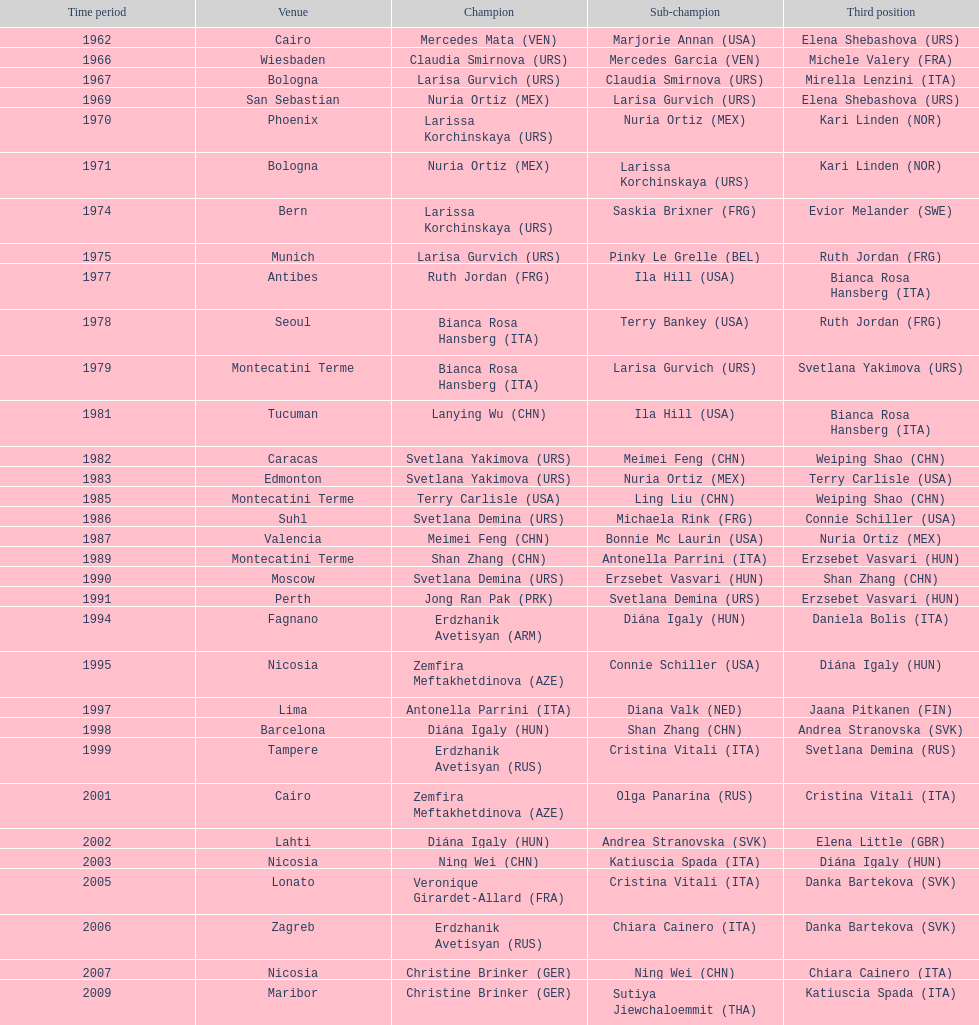How many gold did u.s.a win 1. Can you parse all the data within this table? {'header': ['Time period', 'Venue', 'Champion', 'Sub-champion', 'Third position'], 'rows': [['1962', 'Cairo', 'Mercedes Mata\xa0(VEN)', 'Marjorie Annan\xa0(USA)', 'Elena Shebashova\xa0(URS)'], ['1966', 'Wiesbaden', 'Claudia Smirnova\xa0(URS)', 'Mercedes Garcia\xa0(VEN)', 'Michele Valery\xa0(FRA)'], ['1967', 'Bologna', 'Larisa Gurvich\xa0(URS)', 'Claudia Smirnova\xa0(URS)', 'Mirella Lenzini\xa0(ITA)'], ['1969', 'San Sebastian', 'Nuria Ortiz\xa0(MEX)', 'Larisa Gurvich\xa0(URS)', 'Elena Shebashova\xa0(URS)'], ['1970', 'Phoenix', 'Larissa Korchinskaya\xa0(URS)', 'Nuria Ortiz\xa0(MEX)', 'Kari Linden\xa0(NOR)'], ['1971', 'Bologna', 'Nuria Ortiz\xa0(MEX)', 'Larissa Korchinskaya\xa0(URS)', 'Kari Linden\xa0(NOR)'], ['1974', 'Bern', 'Larissa Korchinskaya\xa0(URS)', 'Saskia Brixner\xa0(FRG)', 'Evior Melander\xa0(SWE)'], ['1975', 'Munich', 'Larisa Gurvich\xa0(URS)', 'Pinky Le Grelle\xa0(BEL)', 'Ruth Jordan\xa0(FRG)'], ['1977', 'Antibes', 'Ruth Jordan\xa0(FRG)', 'Ila Hill\xa0(USA)', 'Bianca Rosa Hansberg\xa0(ITA)'], ['1978', 'Seoul', 'Bianca Rosa Hansberg\xa0(ITA)', 'Terry Bankey\xa0(USA)', 'Ruth Jordan\xa0(FRG)'], ['1979', 'Montecatini Terme', 'Bianca Rosa Hansberg\xa0(ITA)', 'Larisa Gurvich\xa0(URS)', 'Svetlana Yakimova\xa0(URS)'], ['1981', 'Tucuman', 'Lanying Wu\xa0(CHN)', 'Ila Hill\xa0(USA)', 'Bianca Rosa Hansberg\xa0(ITA)'], ['1982', 'Caracas', 'Svetlana Yakimova\xa0(URS)', 'Meimei Feng\xa0(CHN)', 'Weiping Shao\xa0(CHN)'], ['1983', 'Edmonton', 'Svetlana Yakimova\xa0(URS)', 'Nuria Ortiz\xa0(MEX)', 'Terry Carlisle\xa0(USA)'], ['1985', 'Montecatini Terme', 'Terry Carlisle\xa0(USA)', 'Ling Liu\xa0(CHN)', 'Weiping Shao\xa0(CHN)'], ['1986', 'Suhl', 'Svetlana Demina\xa0(URS)', 'Michaela Rink\xa0(FRG)', 'Connie Schiller\xa0(USA)'], ['1987', 'Valencia', 'Meimei Feng\xa0(CHN)', 'Bonnie Mc Laurin\xa0(USA)', 'Nuria Ortiz\xa0(MEX)'], ['1989', 'Montecatini Terme', 'Shan Zhang\xa0(CHN)', 'Antonella Parrini\xa0(ITA)', 'Erzsebet Vasvari\xa0(HUN)'], ['1990', 'Moscow', 'Svetlana Demina\xa0(URS)', 'Erzsebet Vasvari\xa0(HUN)', 'Shan Zhang\xa0(CHN)'], ['1991', 'Perth', 'Jong Ran Pak\xa0(PRK)', 'Svetlana Demina\xa0(URS)', 'Erzsebet Vasvari\xa0(HUN)'], ['1994', 'Fagnano', 'Erdzhanik Avetisyan\xa0(ARM)', 'Diána Igaly\xa0(HUN)', 'Daniela Bolis\xa0(ITA)'], ['1995', 'Nicosia', 'Zemfira Meftakhetdinova\xa0(AZE)', 'Connie Schiller\xa0(USA)', 'Diána Igaly\xa0(HUN)'], ['1997', 'Lima', 'Antonella Parrini\xa0(ITA)', 'Diana Valk\xa0(NED)', 'Jaana Pitkanen\xa0(FIN)'], ['1998', 'Barcelona', 'Diána Igaly\xa0(HUN)', 'Shan Zhang\xa0(CHN)', 'Andrea Stranovska\xa0(SVK)'], ['1999', 'Tampere', 'Erdzhanik Avetisyan\xa0(RUS)', 'Cristina Vitali\xa0(ITA)', 'Svetlana Demina\xa0(RUS)'], ['2001', 'Cairo', 'Zemfira Meftakhetdinova\xa0(AZE)', 'Olga Panarina\xa0(RUS)', 'Cristina Vitali\xa0(ITA)'], ['2002', 'Lahti', 'Diána Igaly\xa0(HUN)', 'Andrea Stranovska\xa0(SVK)', 'Elena Little\xa0(GBR)'], ['2003', 'Nicosia', 'Ning Wei\xa0(CHN)', 'Katiuscia Spada\xa0(ITA)', 'Diána Igaly\xa0(HUN)'], ['2005', 'Lonato', 'Veronique Girardet-Allard\xa0(FRA)', 'Cristina Vitali\xa0(ITA)', 'Danka Bartekova\xa0(SVK)'], ['2006', 'Zagreb', 'Erdzhanik Avetisyan\xa0(RUS)', 'Chiara Cainero\xa0(ITA)', 'Danka Bartekova\xa0(SVK)'], ['2007', 'Nicosia', 'Christine Brinker\xa0(GER)', 'Ning Wei\xa0(CHN)', 'Chiara Cainero\xa0(ITA)'], ['2009', 'Maribor', 'Christine Brinker\xa0(GER)', 'Sutiya Jiewchaloemmit\xa0(THA)', 'Katiuscia Spada\xa0(ITA)']]} 